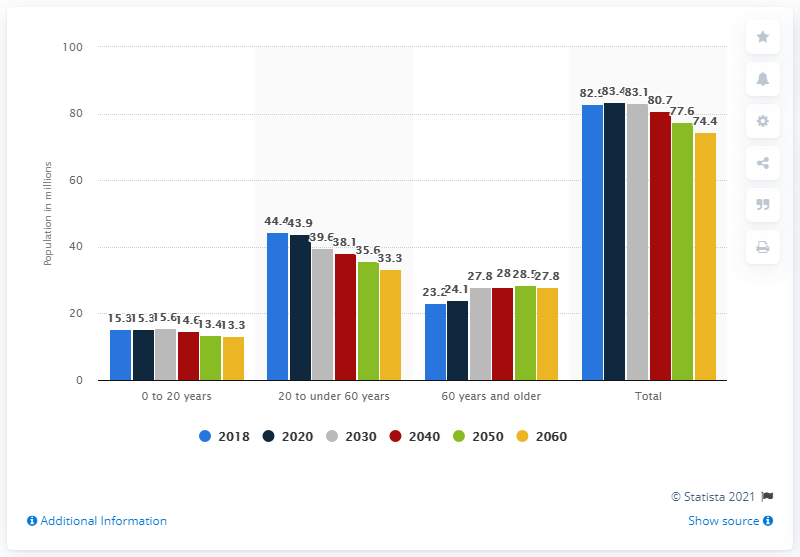Specify some key components in this picture. As of 2020, it is predicted that there will be 15.3 million members in the German population. By 2020, it is predicted that there will be approximately 43.9 people aged 20 to 60 in Germany. 